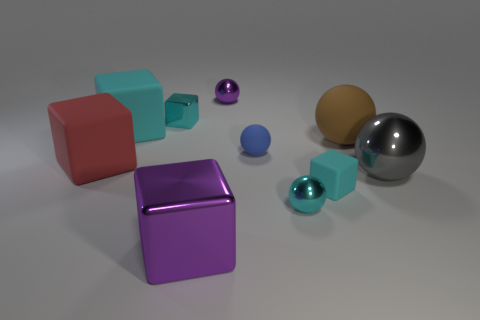Subtract all cyan cylinders. How many cyan cubes are left? 3 Subtract 2 spheres. How many spheres are left? 3 Subtract all purple blocks. How many blocks are left? 4 Subtract all gray spheres. How many spheres are left? 4 Subtract all yellow blocks. Subtract all brown balls. How many blocks are left? 5 Add 4 metal cubes. How many metal cubes exist? 6 Subtract 0 blue cylinders. How many objects are left? 10 Subtract all small cyan metal things. Subtract all large brown rubber balls. How many objects are left? 7 Add 4 red objects. How many red objects are left? 5 